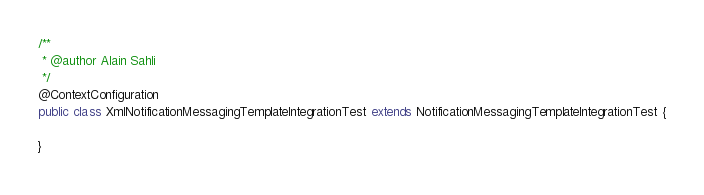<code> <loc_0><loc_0><loc_500><loc_500><_Java_>/**
 * @author Alain Sahli
 */
@ContextConfiguration
public class XmlNotificationMessagingTemplateIntegrationTest extends NotificationMessagingTemplateIntegrationTest {

}
</code> 